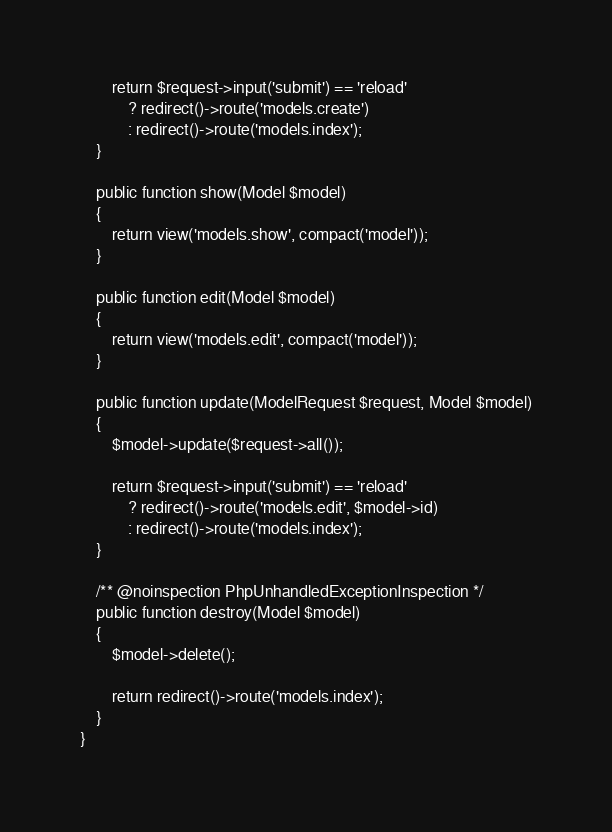Convert code to text. <code><loc_0><loc_0><loc_500><loc_500><_PHP_>
        return $request->input('submit') == 'reload'
            ? redirect()->route('models.create')
            : redirect()->route('models.index');
    }

    public function show(Model $model)
    {
        return view('models.show', compact('model'));
    }

    public function edit(Model $model)
    {
        return view('models.edit', compact('model'));
    }

    public function update(ModelRequest $request, Model $model)
    {
        $model->update($request->all());

        return $request->input('submit') == 'reload'
            ? redirect()->route('models.edit', $model->id)
            : redirect()->route('models.index');
    }

    /** @noinspection PhpUnhandledExceptionInspection */
    public function destroy(Model $model)
    {
        $model->delete();

        return redirect()->route('models.index');
    }
}
</code> 